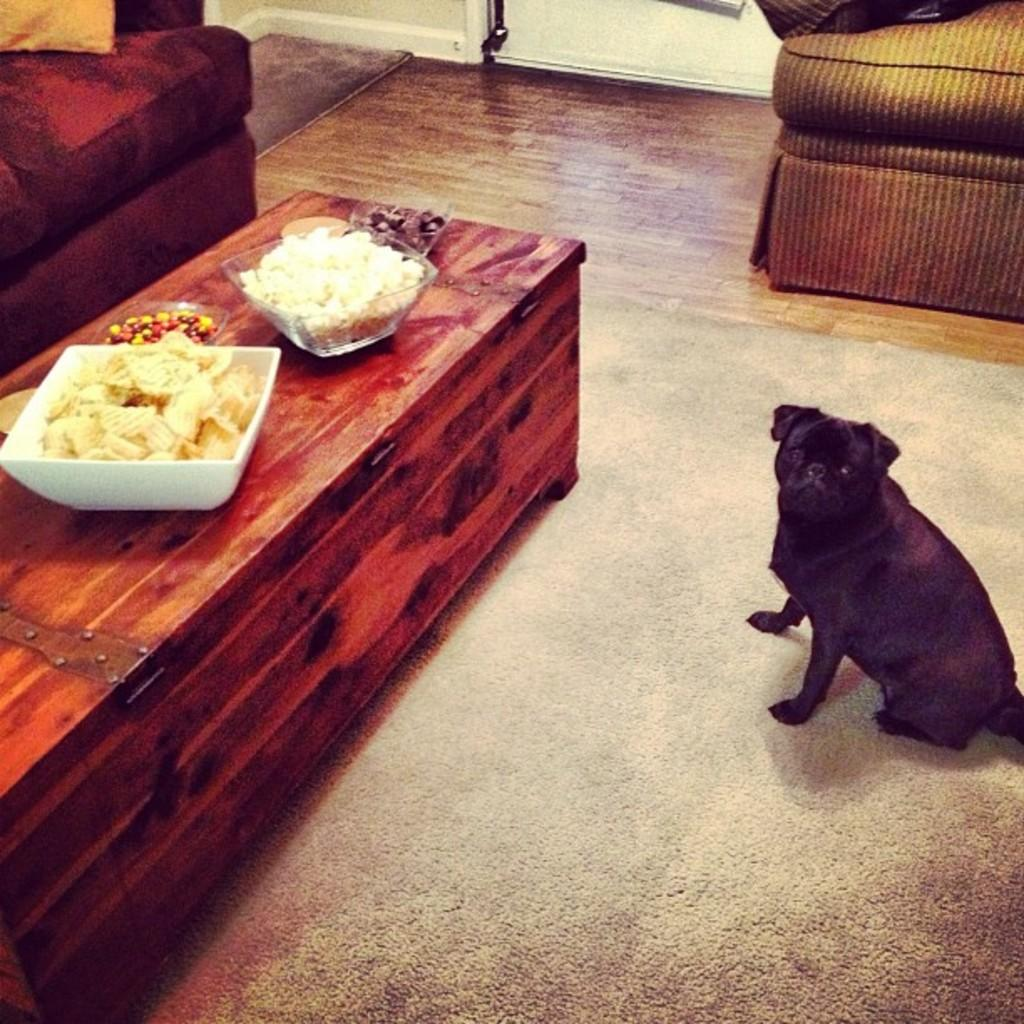What animal is sitting on the floor in the image? There is a dog sitting on the floor in the image. What can be seen on the table in the image? There are things to eat on the table in the image. What type of furniture is visible in the background of the image? There is a couch in the background of the image. What is the main feature of the room that can be seen in the image? There is a wall visible in the image. How does the dog feel shame in the image? There is no indication of the dog feeling shame in the image; it is simply sitting on the floor. 